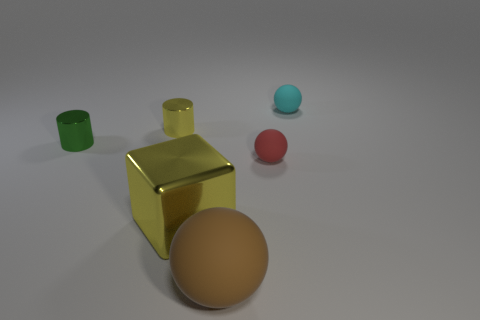Does the large ball have the same material as the cyan sphere?
Your answer should be very brief. Yes. Is there anything else that is the same shape as the large shiny object?
Give a very brief answer. No. There is a yellow thing that is left of the big object that is behind the brown rubber object; what is it made of?
Provide a short and direct response. Metal. What is the size of the shiny object on the left side of the tiny yellow thing?
Offer a terse response. Small. There is a rubber thing that is both behind the big rubber object and in front of the small cyan matte object; what color is it?
Offer a terse response. Red. Does the yellow metal object behind the block have the same size as the tiny cyan object?
Keep it short and to the point. Yes. Is there a red rubber ball left of the large thing that is behind the big brown matte object?
Keep it short and to the point. No. What material is the brown thing?
Provide a short and direct response. Rubber. There is a yellow block; are there any tiny green metallic cylinders behind it?
Ensure brevity in your answer.  Yes. There is a brown rubber object that is the same shape as the tiny red matte object; what size is it?
Make the answer very short. Large. 